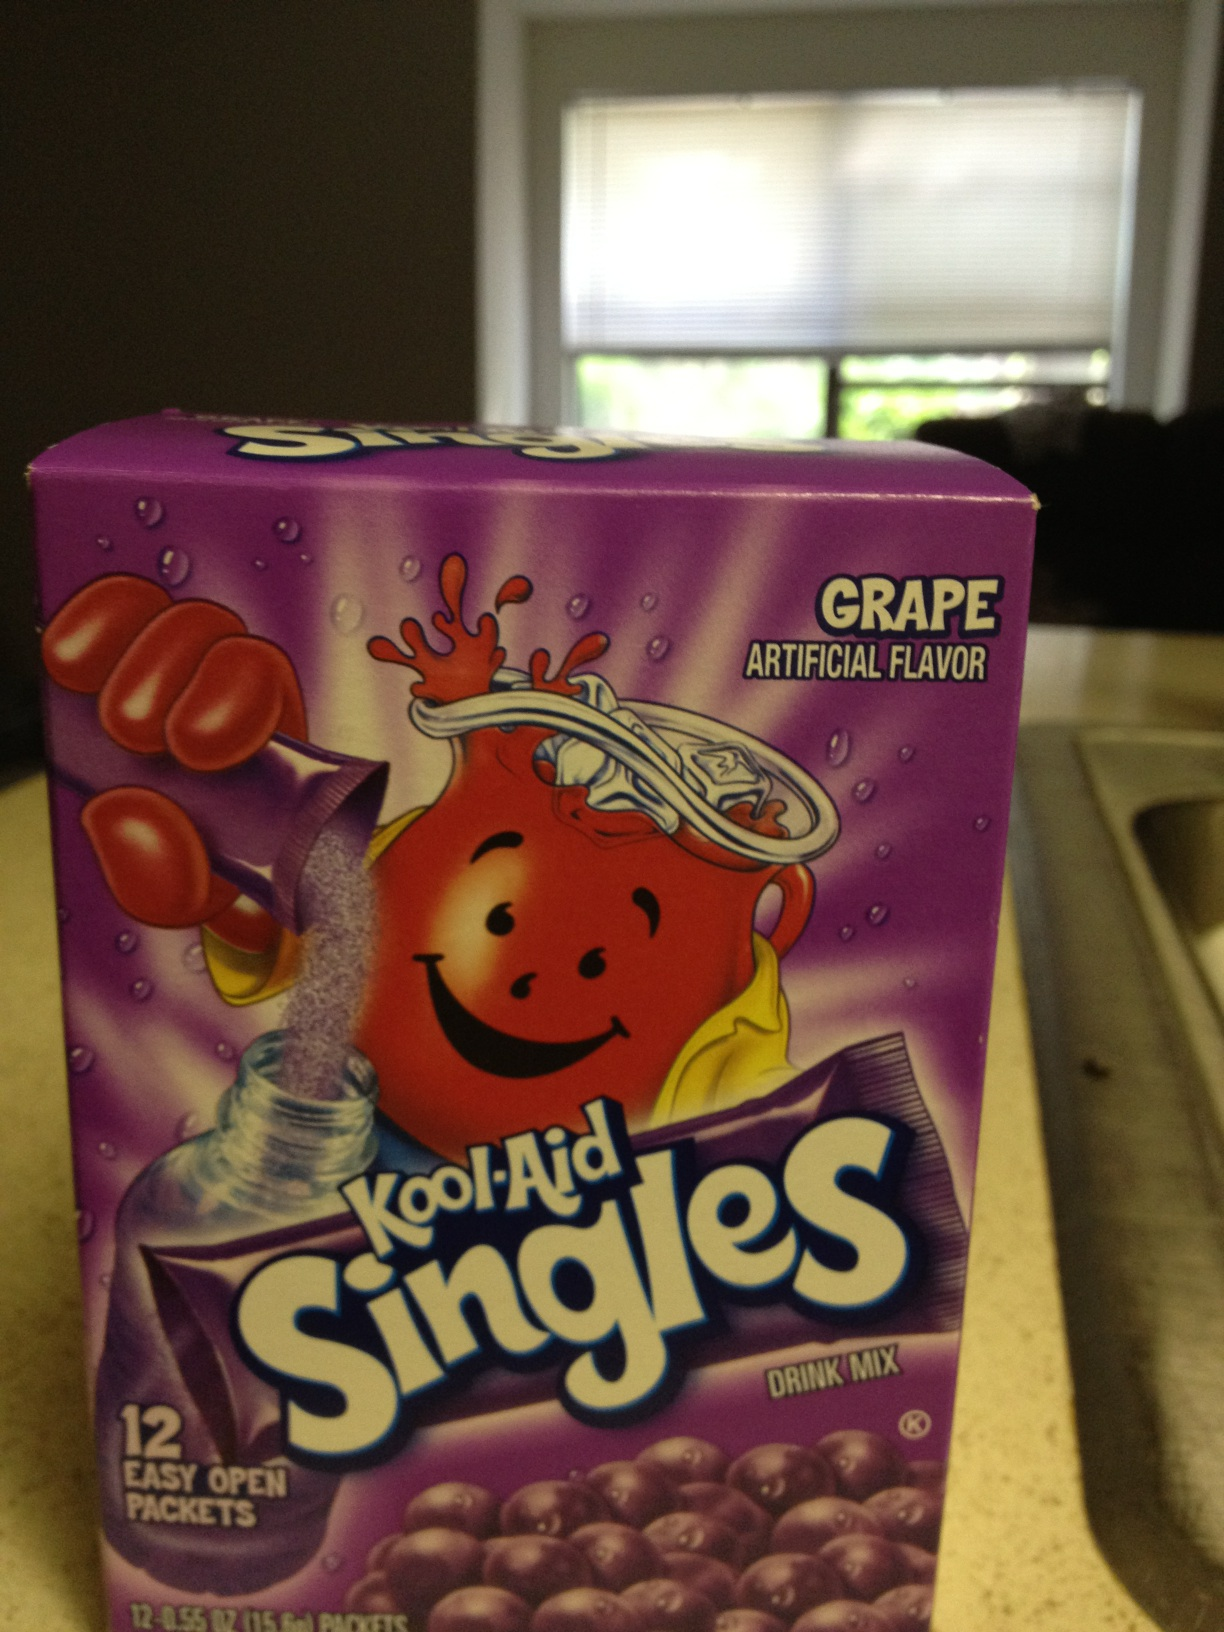What's the appeal of artificial flavors in drinks like this? Artificial flavors in drinks like Kool-Aid provide a consistent and strong taste that can closely mimic natural flavors or create unique flavors. They are also cost-effective and allow for longer shelf life of the products. Are there any health concerns related to artificial flavors? Yes, there are some concerns. While most artificial flavors are safe and approved by food safety authorities, excessive consumption can be unhealthy. It's always best to consume them in moderation as part of a balanced diet. 